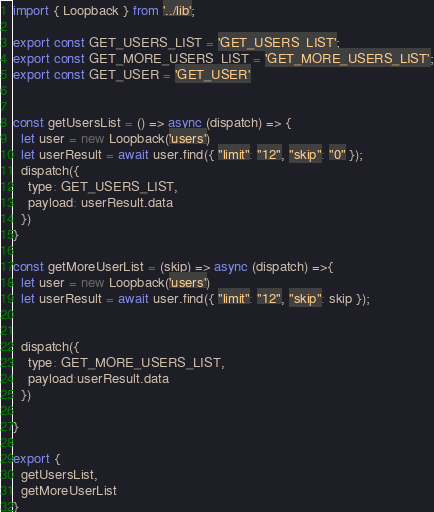<code> <loc_0><loc_0><loc_500><loc_500><_JavaScript_>import { Loopback } from '../lib';

export const GET_USERS_LIST = 'GET_USERS_LIST';
export const GET_MORE_USERS_LIST = 'GET_MORE_USERS_LIST';
export const GET_USER = 'GET_USER'


const getUsersList = () => async (dispatch) => {
  let user = new Loopback('users')
  let userResult = await user.find({ "limit": "12", "skip": "0" });
  dispatch({
    type: GET_USERS_LIST,
    payload: userResult.data
  })
}

const getMoreUserList = (skip) => async (dispatch) =>{
  let user = new Loopback('users')
  let userResult = await user.find({ "limit": "12", "skip": skip });


  dispatch({
    type: GET_MORE_USERS_LIST,
    payload:userResult.data
  })

}

export {
  getUsersList,
  getMoreUserList
}
</code> 